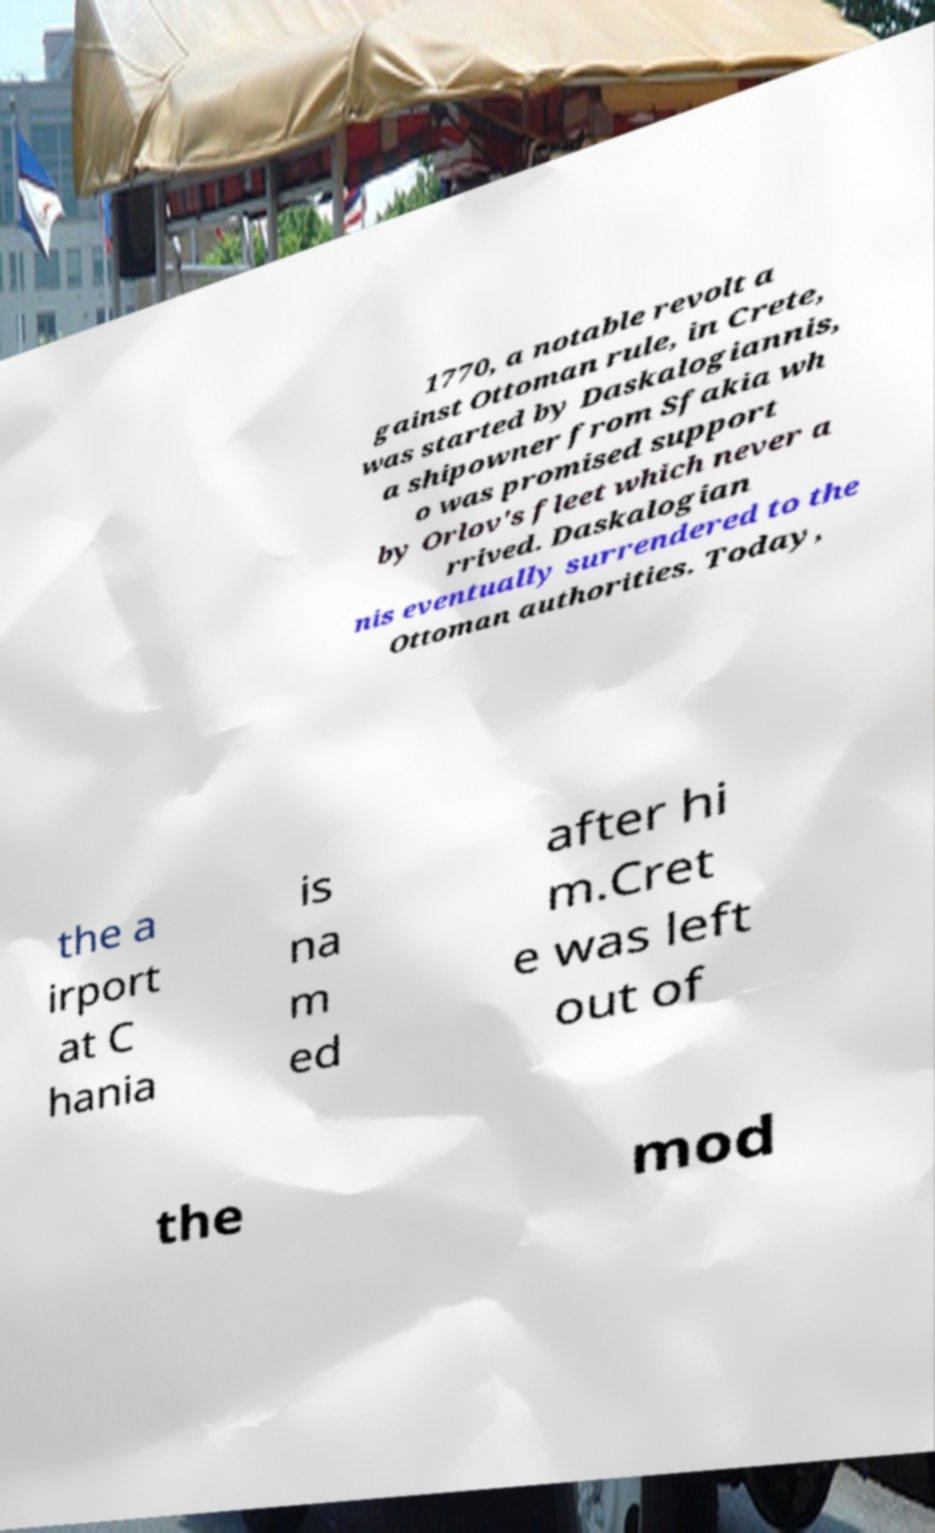There's text embedded in this image that I need extracted. Can you transcribe it verbatim? 1770, a notable revolt a gainst Ottoman rule, in Crete, was started by Daskalogiannis, a shipowner from Sfakia wh o was promised support by Orlov's fleet which never a rrived. Daskalogian nis eventually surrendered to the Ottoman authorities. Today, the a irport at C hania is na m ed after hi m.Cret e was left out of the mod 